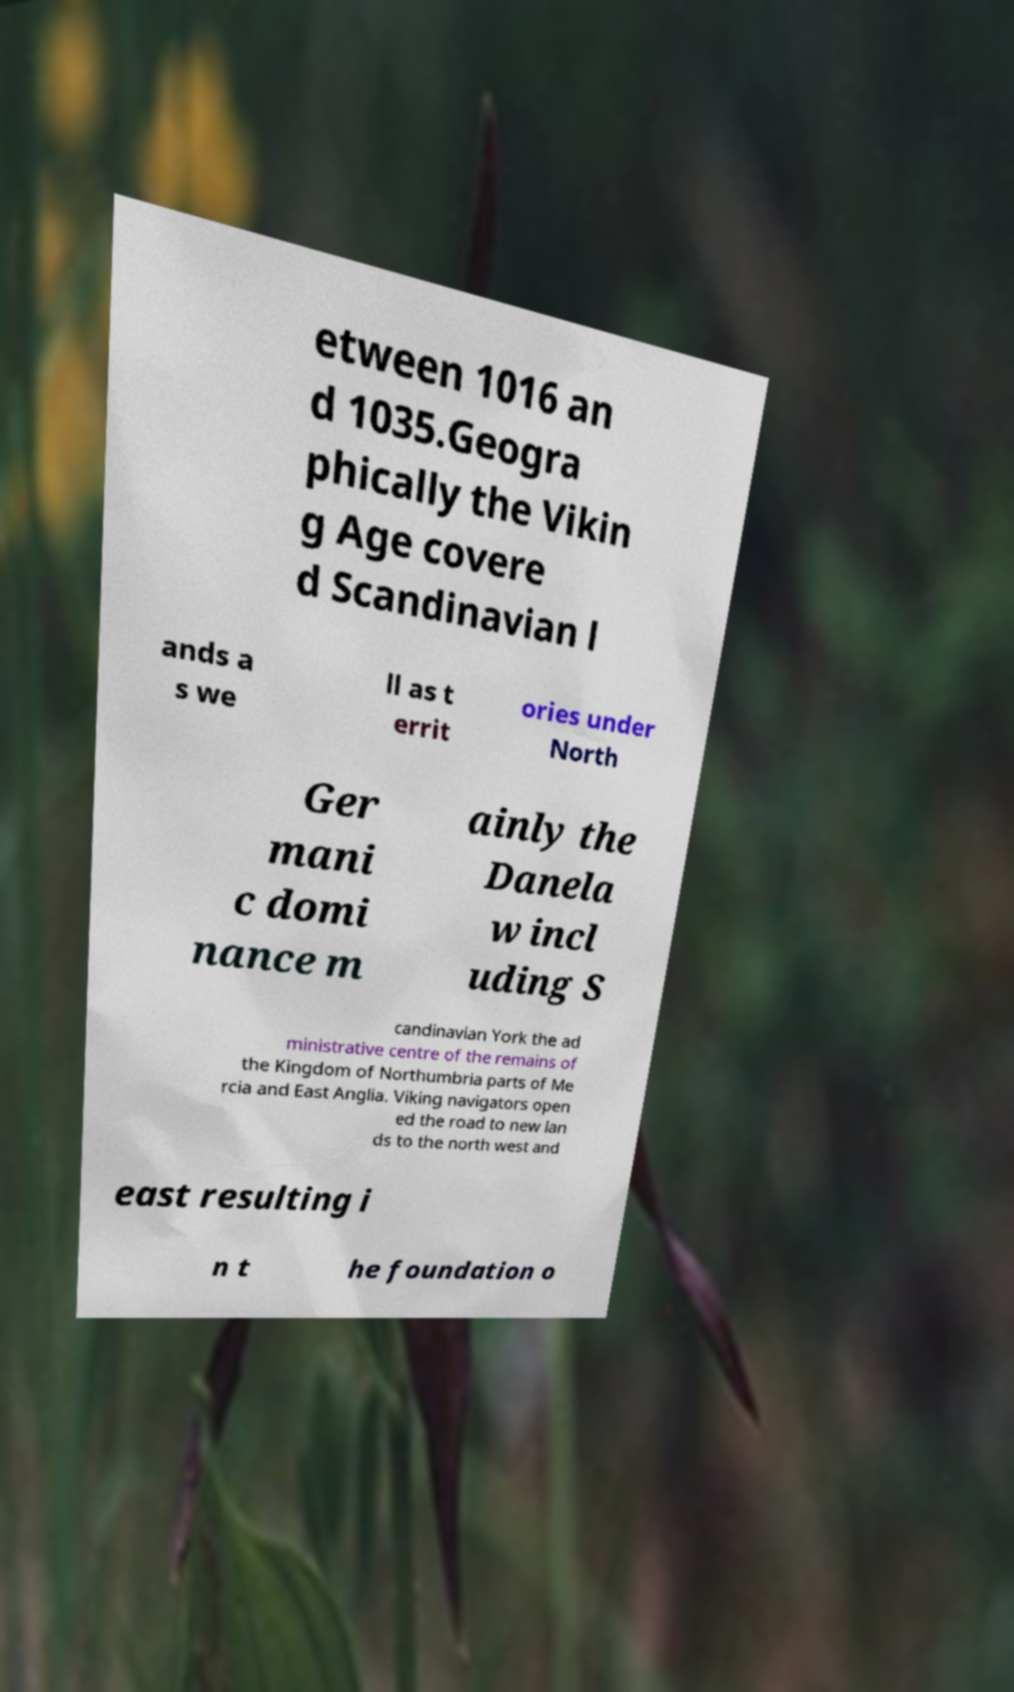Can you read and provide the text displayed in the image?This photo seems to have some interesting text. Can you extract and type it out for me? etween 1016 an d 1035.Geogra phically the Vikin g Age covere d Scandinavian l ands a s we ll as t errit ories under North Ger mani c domi nance m ainly the Danela w incl uding S candinavian York the ad ministrative centre of the remains of the Kingdom of Northumbria parts of Me rcia and East Anglia. Viking navigators open ed the road to new lan ds to the north west and east resulting i n t he foundation o 